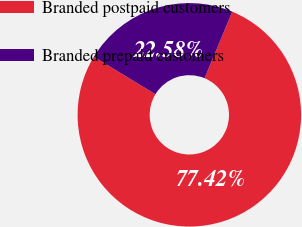Convert chart. <chart><loc_0><loc_0><loc_500><loc_500><pie_chart><fcel>Branded postpaid customers<fcel>Branded prepaid customers<nl><fcel>77.42%<fcel>22.58%<nl></chart> 